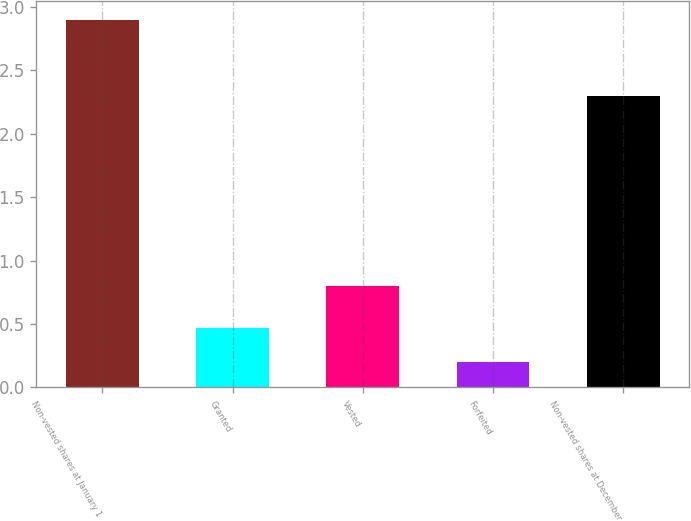<chart> <loc_0><loc_0><loc_500><loc_500><bar_chart><fcel>Non-vested shares at January 1<fcel>Granted<fcel>Vested<fcel>Forfeited<fcel>Non-vested shares at December<nl><fcel>2.9<fcel>0.47<fcel>0.8<fcel>0.2<fcel>2.3<nl></chart> 